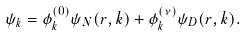<formula> <loc_0><loc_0><loc_500><loc_500>\psi _ { k } = \phi _ { k } ^ { ( 0 ) } \psi _ { N } ( r , k ) + \phi _ { k } ^ { ( \nu ) } \psi _ { D } ( r , k ) .</formula> 